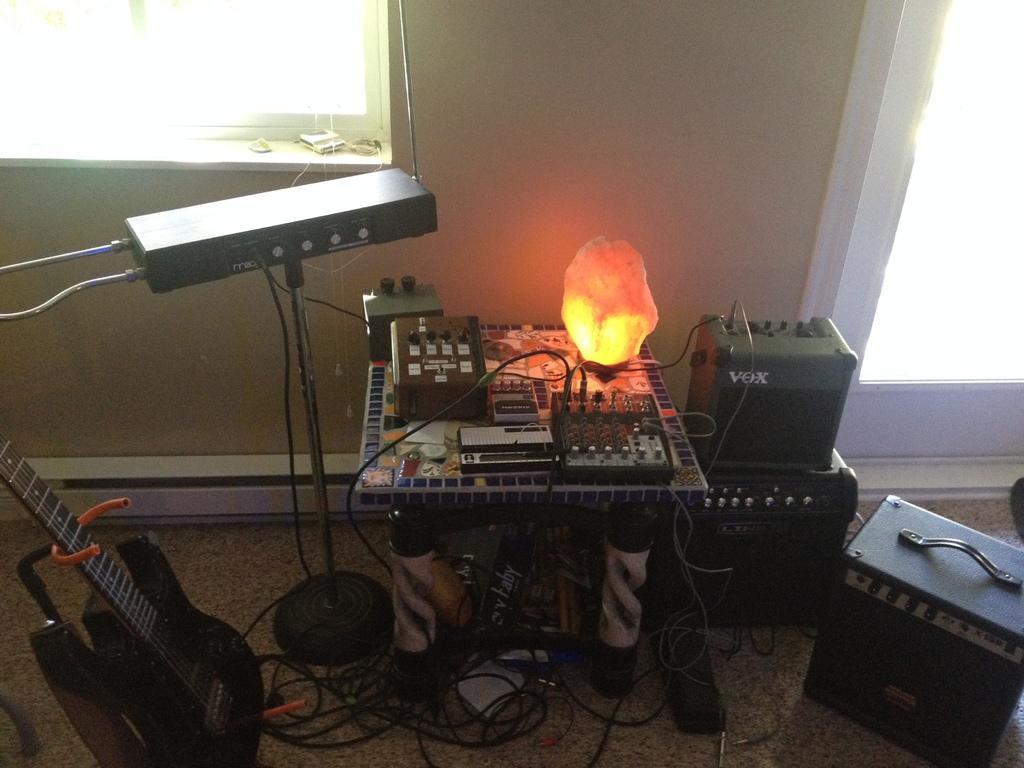Please provide a concise description of this image. This image consists of a guitar placed on the ground and few music equipment placed around, there is a table in the center with a light on it. Behind there is a window. 